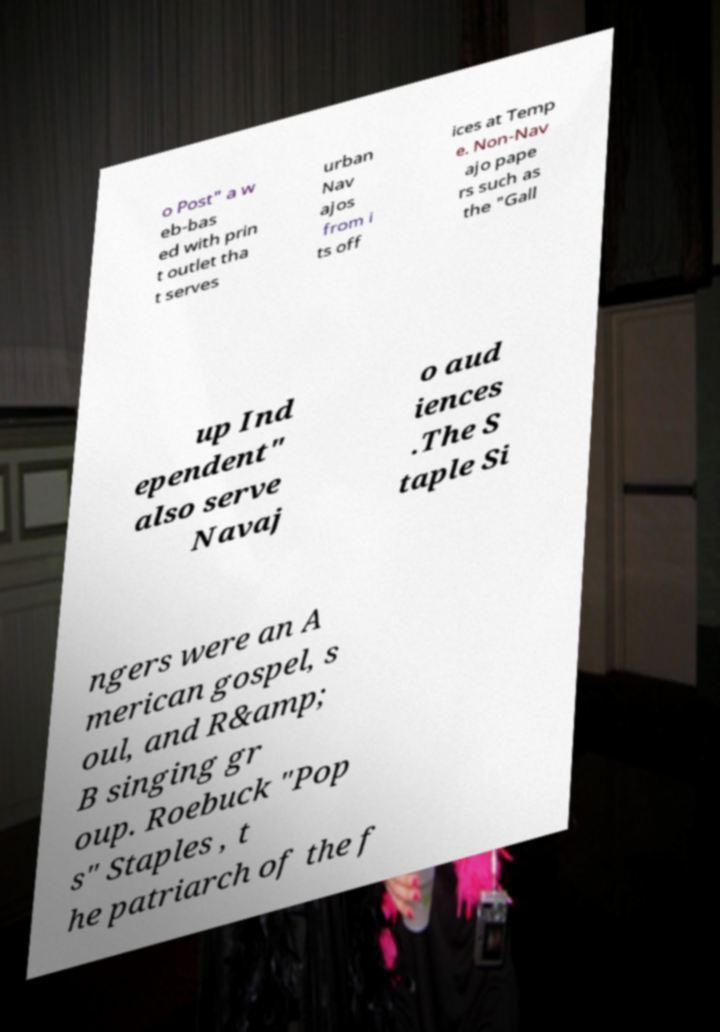I need the written content from this picture converted into text. Can you do that? o Post" a w eb-bas ed with prin t outlet tha t serves urban Nav ajos from i ts off ices at Temp e. Non-Nav ajo pape rs such as the "Gall up Ind ependent" also serve Navaj o aud iences .The S taple Si ngers were an A merican gospel, s oul, and R&amp; B singing gr oup. Roebuck "Pop s" Staples , t he patriarch of the f 